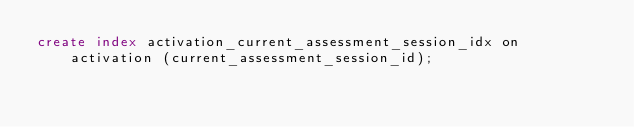Convert code to text. <code><loc_0><loc_0><loc_500><loc_500><_SQL_>create index activation_current_assessment_session_idx on activation (current_assessment_session_id);


</code> 